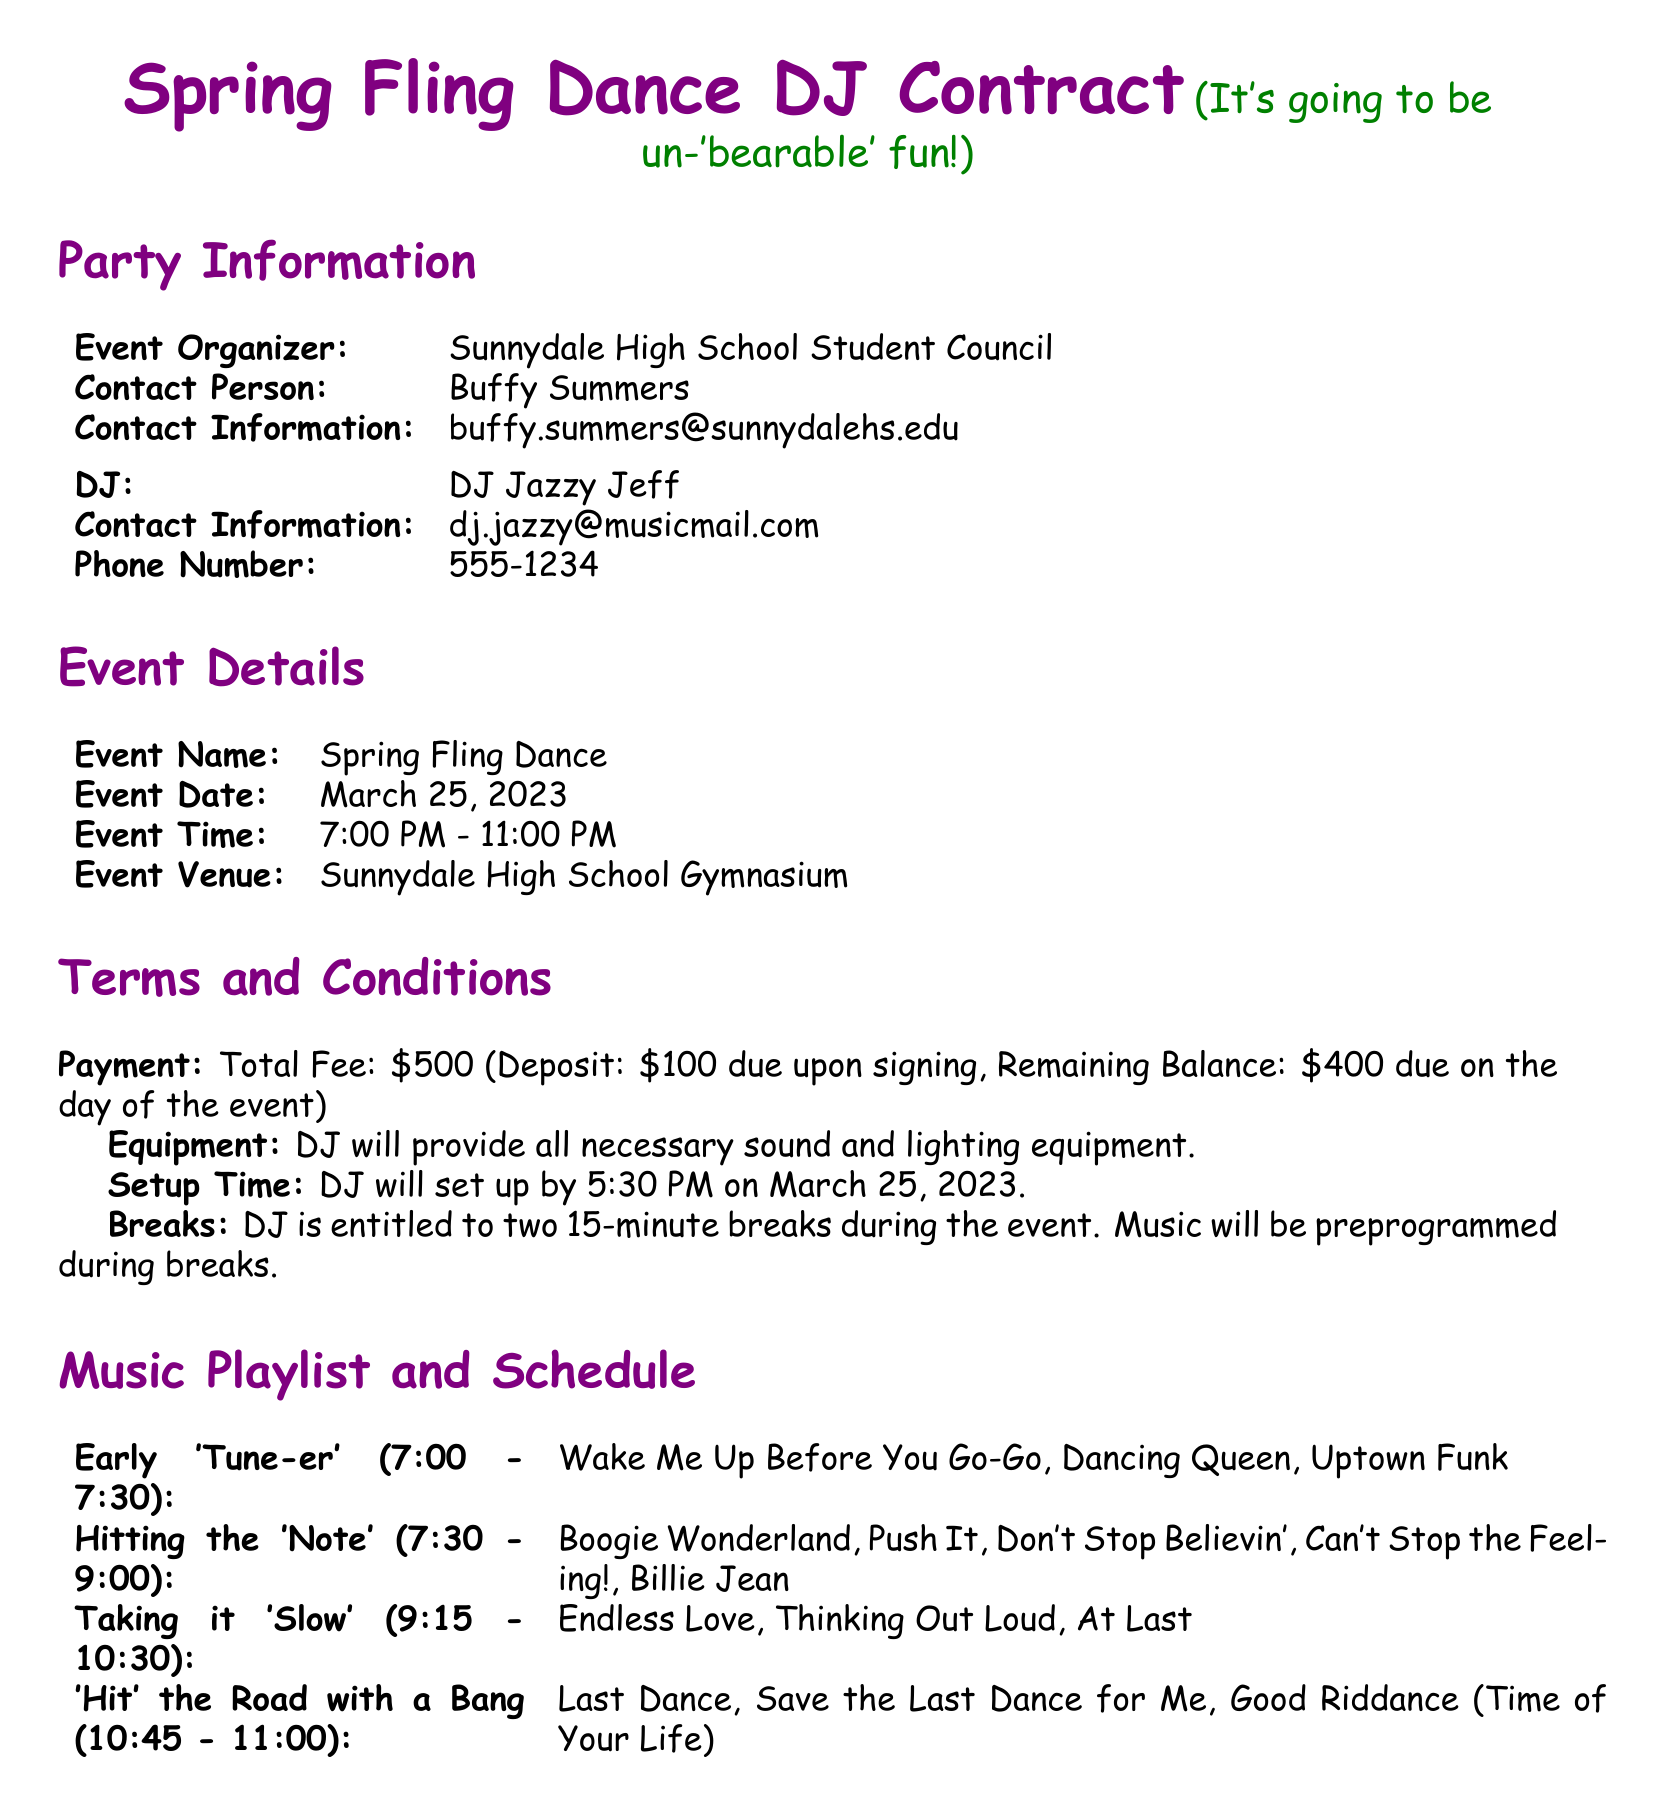What is the event name? The event name is listed under the Event Details section of the document, which is the Spring Fling Dance.
Answer: Spring Fling Dance Who is the contact person for the event? The contact person is mentioned in the Party Information section as Buffy Summers.
Answer: Buffy Summers What is the total fee for the DJ services? The total fee is specified in the Terms and Conditions section of the document.
Answer: $500 What time does the DJ's closing set start? The start time for the closing set is indicated under the Music Playlist and Schedule section of the document.
Answer: 10:45 PM How many 15-minute breaks does the DJ get during the event? This information can be found in the Terms and Conditions section, which specifies the number of breaks.
Answer: Two What time is the DJ expected to set up by? The setup time is mentioned in the Terms and Conditions section.
Answer: 5:30 PM What color is used for the document's section titles? The colors used for the titles are defined in the document's preamble, specifically for section titles.
Answer: Funpurple What is the venue for the Spring Fling Dance? The venue is listed in the Event Details section of the document.
Answer: Sunnydale High School Gymnasium 